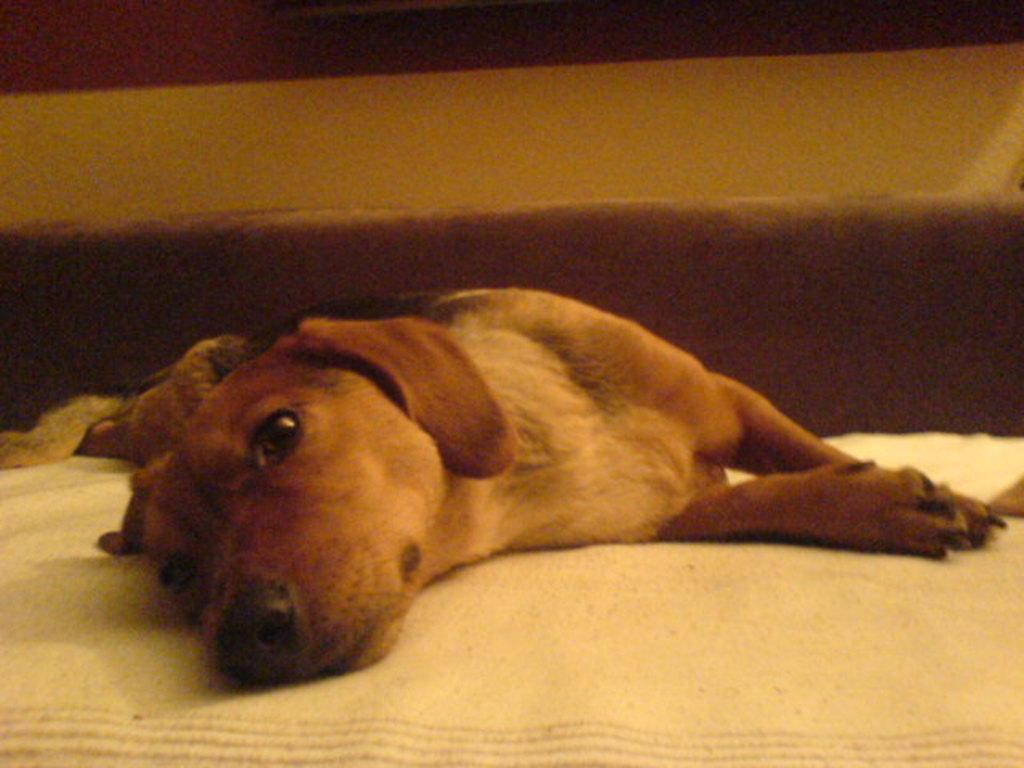What animal is present in the image? There is a dog in the image. What is the dog laying on? The dog is laying on a cloth. Can you describe the background of the image? The background of the image is blurry. What type of plant is growing on the dog in the image? There is no plant growing on the dog in the image. What is the dog's annual income in the image? The image does not provide information about the dog's income. 